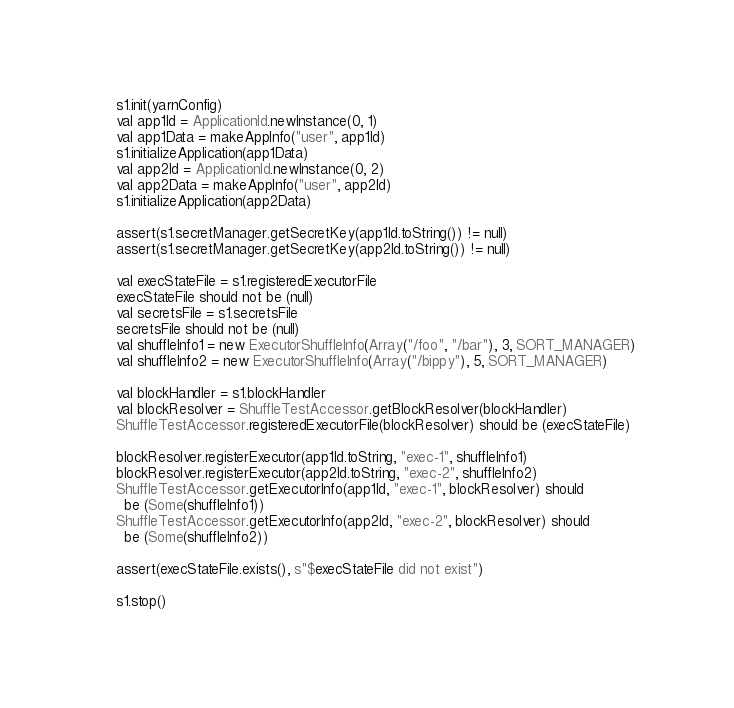Convert code to text. <code><loc_0><loc_0><loc_500><loc_500><_Scala_>    s1.init(yarnConfig)
    val app1Id = ApplicationId.newInstance(0, 1)
    val app1Data = makeAppInfo("user", app1Id)
    s1.initializeApplication(app1Data)
    val app2Id = ApplicationId.newInstance(0, 2)
    val app2Data = makeAppInfo("user", app2Id)
    s1.initializeApplication(app2Data)

    assert(s1.secretManager.getSecretKey(app1Id.toString()) != null)
    assert(s1.secretManager.getSecretKey(app2Id.toString()) != null)

    val execStateFile = s1.registeredExecutorFile
    execStateFile should not be (null)
    val secretsFile = s1.secretsFile
    secretsFile should not be (null)
    val shuffleInfo1 = new ExecutorShuffleInfo(Array("/foo", "/bar"), 3, SORT_MANAGER)
    val shuffleInfo2 = new ExecutorShuffleInfo(Array("/bippy"), 5, SORT_MANAGER)

    val blockHandler = s1.blockHandler
    val blockResolver = ShuffleTestAccessor.getBlockResolver(blockHandler)
    ShuffleTestAccessor.registeredExecutorFile(blockResolver) should be (execStateFile)

    blockResolver.registerExecutor(app1Id.toString, "exec-1", shuffleInfo1)
    blockResolver.registerExecutor(app2Id.toString, "exec-2", shuffleInfo2)
    ShuffleTestAccessor.getExecutorInfo(app1Id, "exec-1", blockResolver) should
      be (Some(shuffleInfo1))
    ShuffleTestAccessor.getExecutorInfo(app2Id, "exec-2", blockResolver) should
      be (Some(shuffleInfo2))

    assert(execStateFile.exists(), s"$execStateFile did not exist")

    s1.stop()
</code> 